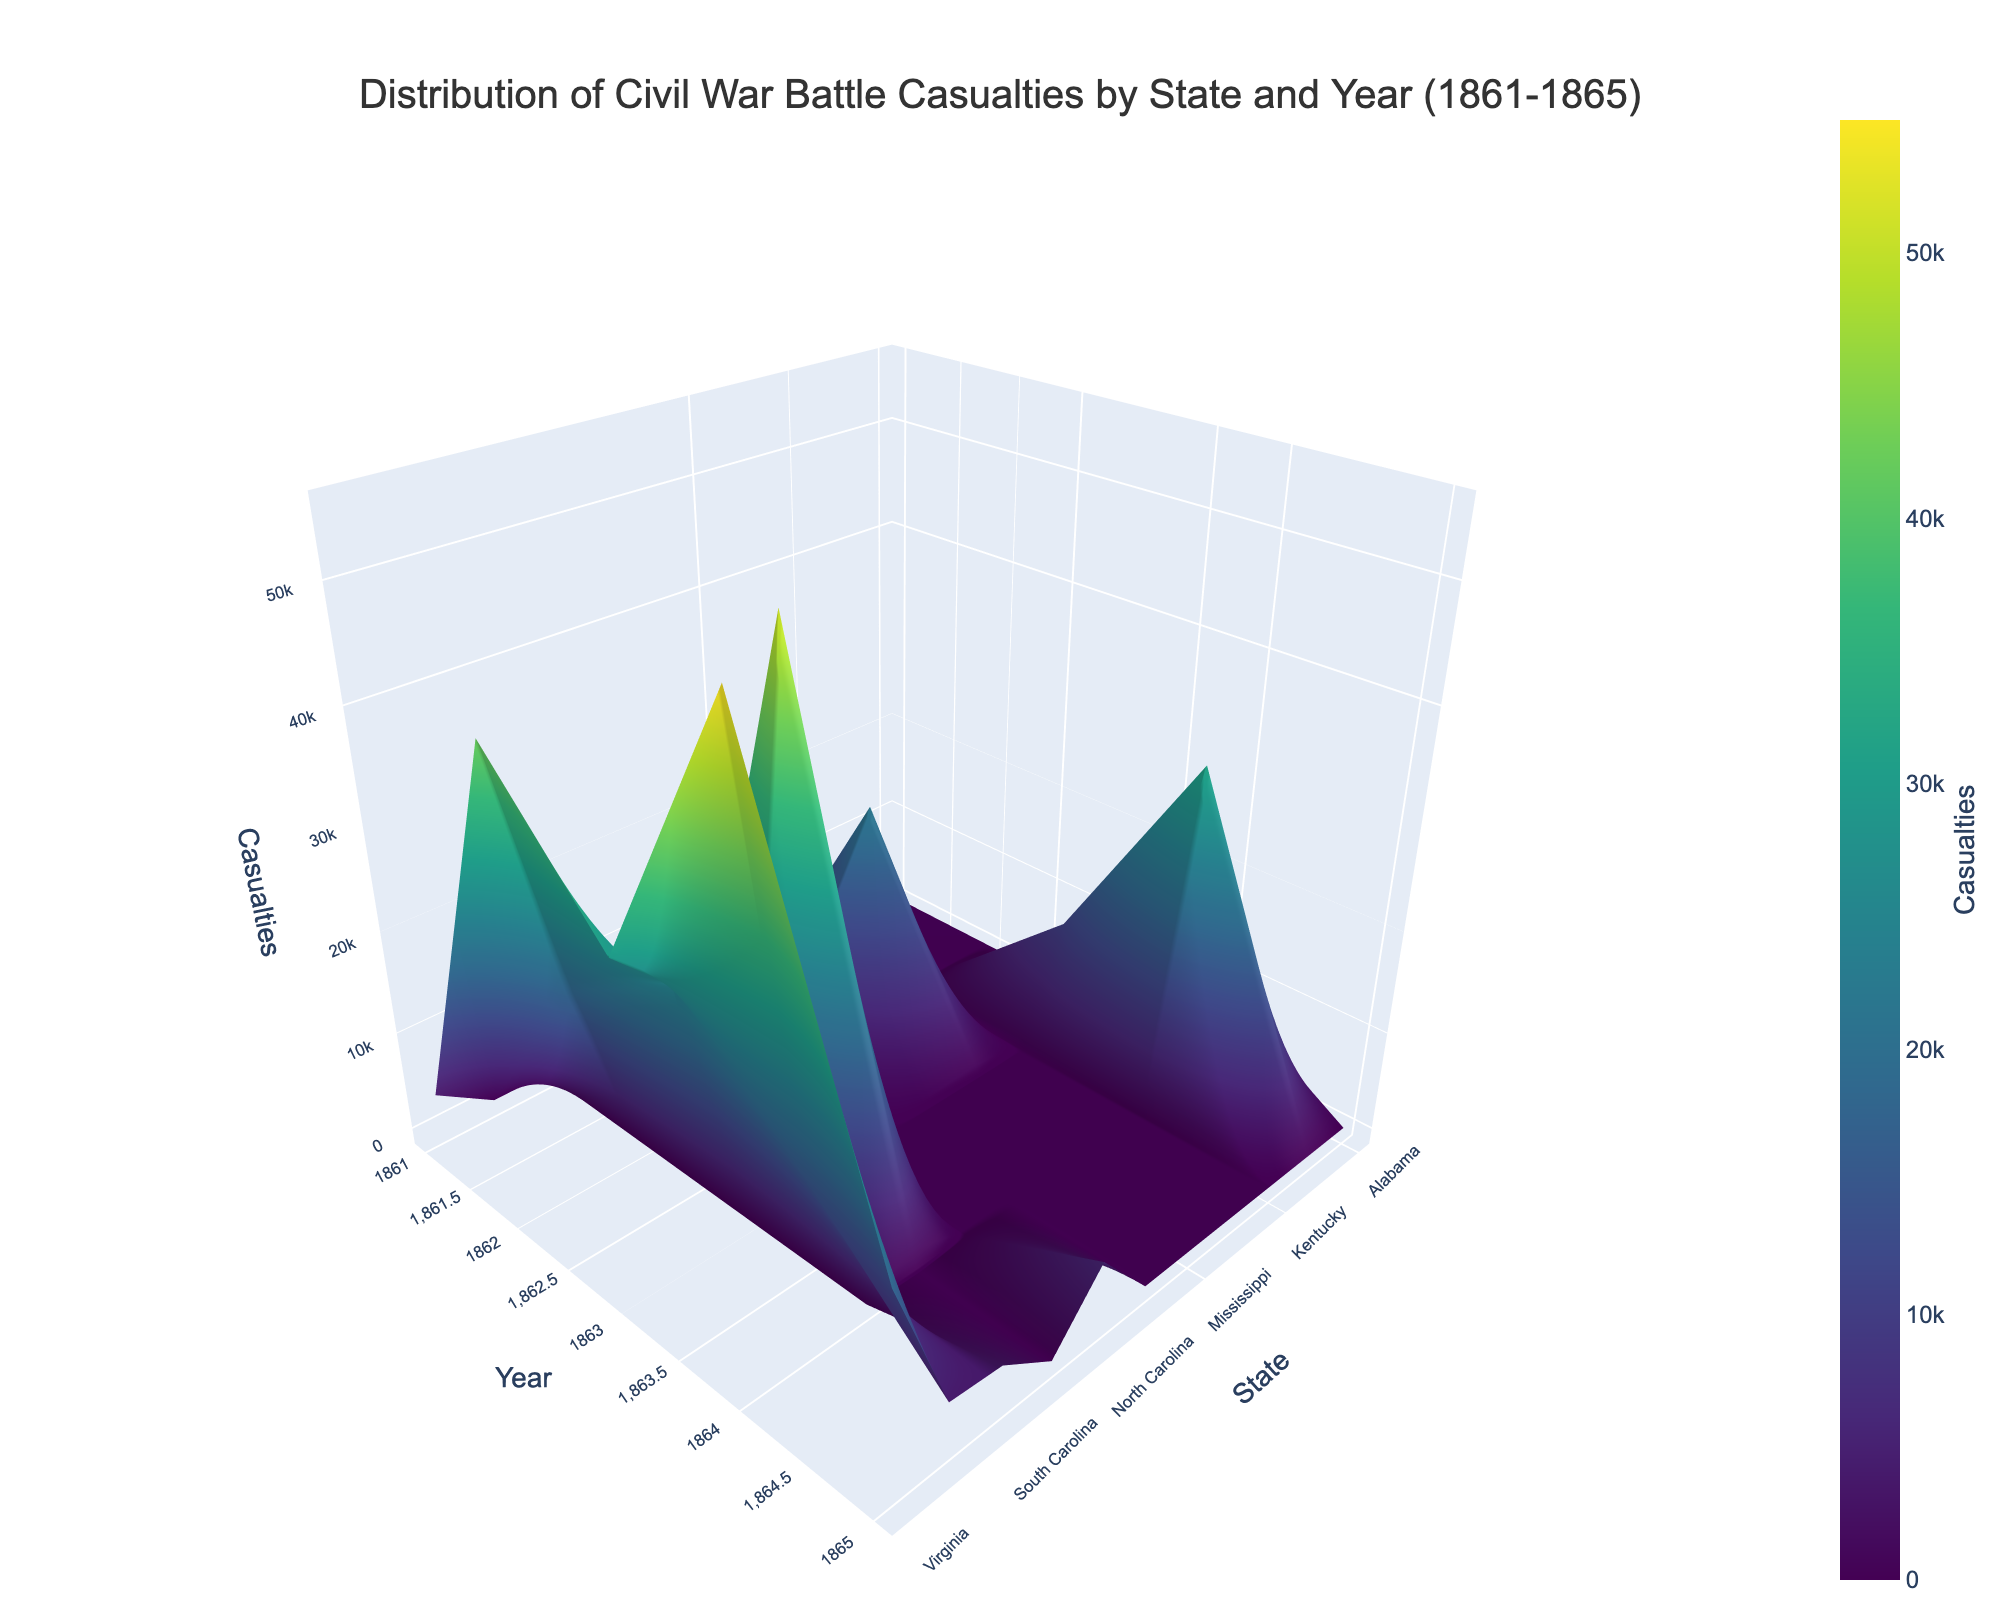What is the highest casualty count recorded in the plot? To find the highest casualty count, look for the tallest peak on the surface plot. This peak represents the year and state with the most casualties.
Answer: 55,000 In which state did the highest casualty count occur in 1862? To answer this, check the surface levels corresponding to 1862 in different states and identify the highest point.
Answer: Virginia Which year shows the highest overall battle casualty count across all states? To determine this, review each year's peak heights in the plot and identify which year's peaks are the tallest.
Answer: 1864 How did the battle casualties in Georgia change from 1863 to 1864? Compare the heights of the surface plot for Georgia in the years 1863 and 1864. 1863 had a lower peak, while 1864 had a noticeably higher peak.
Answer: Increased Which states had battle casualties in each of the five years from 1861 to 1865? Look for states that have peaks or data points across all five years along the x-axis for states and the y-axis for years.
Answer: Tennessee, Virginia What is the approximate average number of casualties in Tennessee from 1862 to 1865? First, find the heights of the peaks corresponding to Tennessee for each year from 1862 to 1865 (18,000 + 25,000 + 15,000 + 4,000). Then, sum these values and divide by 4 to get the average.
Answer: 15,500 Which state had the second-highest number of casualties in 1864? In 1864, observe the surface plot's peaks and find the second-highest peak. The highest is Virginia, so check the next highest peak.
Answer: Georgia Are there any states that only have battle casualties reported in one year? Identify the states with only one peak on the surface plot, where there is a noticeable point for just one year.
Answer: Missouri, Kentucky, Maryland, North Carolina, South Carolina Which region has the highest variance in casualties over the years? Look for states with significant fluctuations in the peaks across the years in the surface plot. Note where the heights vary the most dramatically.
Answer: Virginia 